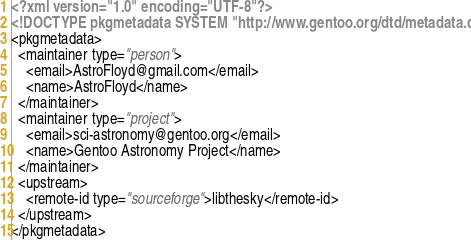<code> <loc_0><loc_0><loc_500><loc_500><_XML_><?xml version="1.0" encoding="UTF-8"?>
<!DOCTYPE pkgmetadata SYSTEM "http://www.gentoo.org/dtd/metadata.dtd">
<pkgmetadata>
  <maintainer type="person">
    <email>AstroFloyd@gmail.com</email>
    <name>AstroFloyd</name>
  </maintainer>
  <maintainer type="project">
    <email>sci-astronomy@gentoo.org</email>
    <name>Gentoo Astronomy Project</name>
  </maintainer>
  <upstream>
    <remote-id type="sourceforge">libthesky</remote-id>
  </upstream>
</pkgmetadata>
</code> 